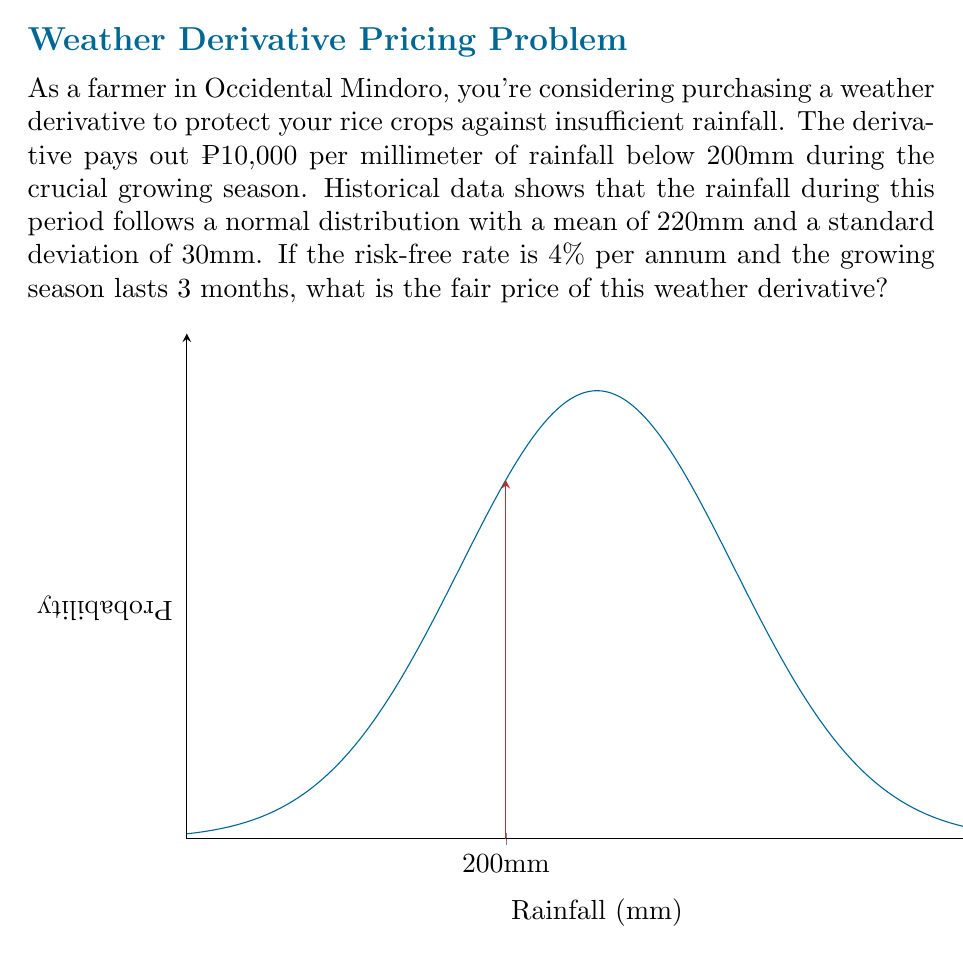Solve this math problem. Let's approach this step-by-step:

1) First, we need to calculate the probability of rainfall being below 200mm. We can use the z-score formula:

   $z = \frac{x - \mu}{\sigma} = \frac{200 - 220}{30} = -\frac{2}{3}$

2) Using a standard normal distribution table or calculator, we find:

   $P(X < 200) = \Phi(-\frac{2}{3}) \approx 0.2525$

3) Now, we need to calculate the expected payout. For this, we need the expected shortfall below 200mm:

   $E[\max(200-X, 0)] = (200-220)\Phi(-\frac{2}{3}) + 30\phi(-\frac{2}{3})$

   Where $\phi$ is the standard normal PDF. This equals:

   $(-20 * 0.2525) + (30 * 0.3210) = 4.5780$

4) The expected payout is thus:

   $10,000 * 4.5780 = ₱45,780$

5) To get the present value, we discount this amount at the risk-free rate for 3 months:

   $PV = 45,780 * e^{-0.04 * \frac{3}{12}} = 45,780 * e^{-0.01} \approx ₱45,324.62$

Therefore, the fair price of the weather derivative is approximately ₱45,324.62.
Answer: ₱45,324.62 